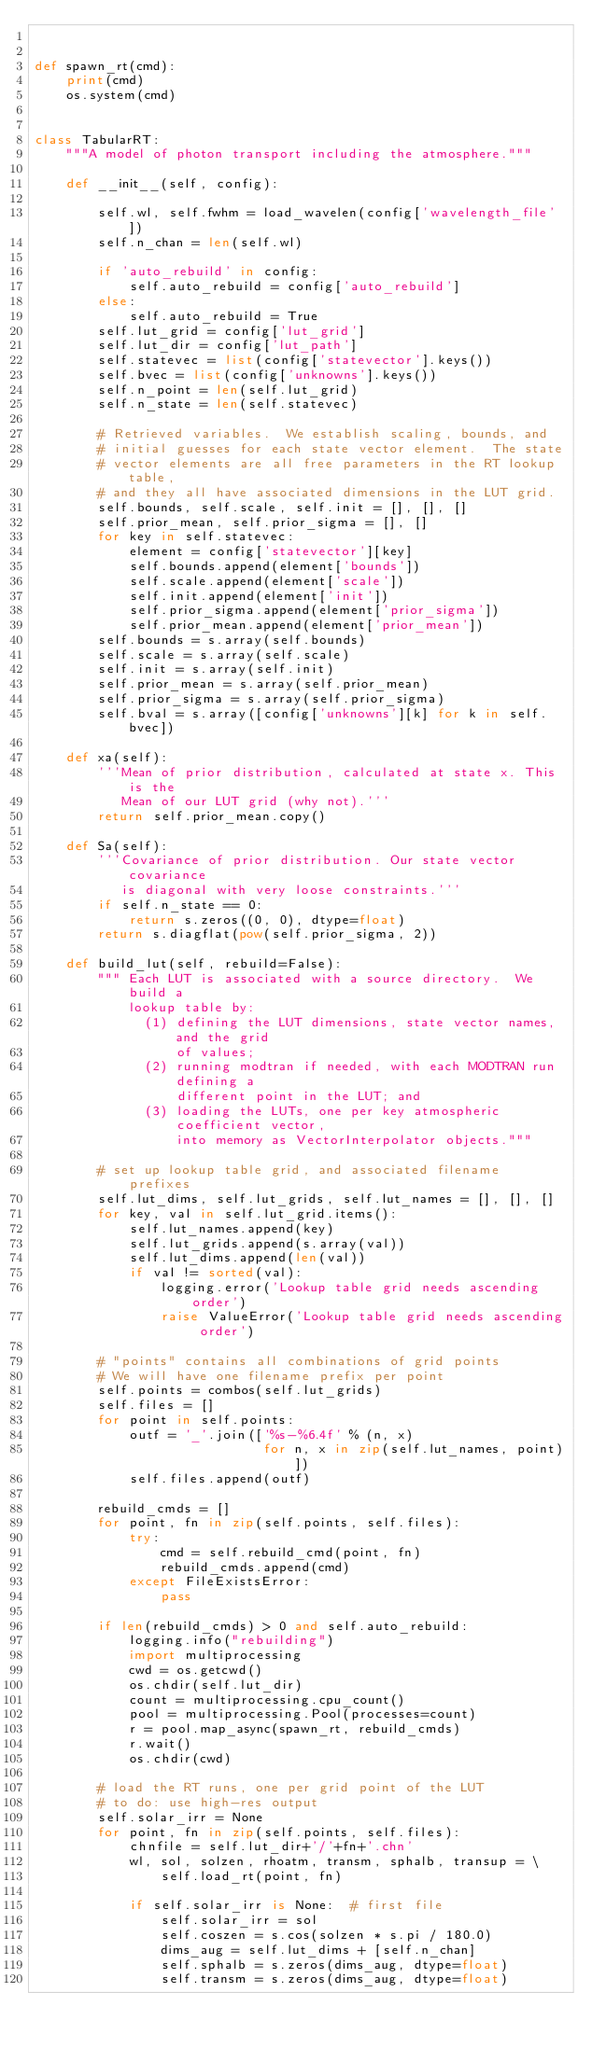<code> <loc_0><loc_0><loc_500><loc_500><_Python_>

def spawn_rt(cmd):
    print(cmd)
    os.system(cmd)


class TabularRT:
    """A model of photon transport including the atmosphere."""

    def __init__(self, config):

        self.wl, self.fwhm = load_wavelen(config['wavelength_file'])
        self.n_chan = len(self.wl)

        if 'auto_rebuild' in config:
            self.auto_rebuild = config['auto_rebuild']
        else:
            self.auto_rebuild = True
        self.lut_grid = config['lut_grid']
        self.lut_dir = config['lut_path']
        self.statevec = list(config['statevector'].keys())
        self.bvec = list(config['unknowns'].keys())
        self.n_point = len(self.lut_grid)
        self.n_state = len(self.statevec)

        # Retrieved variables.  We establish scaling, bounds, and
        # initial guesses for each state vector element.  The state
        # vector elements are all free parameters in the RT lookup table,
        # and they all have associated dimensions in the LUT grid.
        self.bounds, self.scale, self.init = [], [], []
        self.prior_mean, self.prior_sigma = [], []
        for key in self.statevec:
            element = config['statevector'][key]
            self.bounds.append(element['bounds'])
            self.scale.append(element['scale'])
            self.init.append(element['init'])
            self.prior_sigma.append(element['prior_sigma'])
            self.prior_mean.append(element['prior_mean'])
        self.bounds = s.array(self.bounds)
        self.scale = s.array(self.scale)
        self.init = s.array(self.init)
        self.prior_mean = s.array(self.prior_mean)
        self.prior_sigma = s.array(self.prior_sigma)
        self.bval = s.array([config['unknowns'][k] for k in self.bvec])

    def xa(self):
        '''Mean of prior distribution, calculated at state x. This is the
           Mean of our LUT grid (why not).'''
        return self.prior_mean.copy()

    def Sa(self):
        '''Covariance of prior distribution. Our state vector covariance 
           is diagonal with very loose constraints.'''
        if self.n_state == 0:
            return s.zeros((0, 0), dtype=float)
        return s.diagflat(pow(self.prior_sigma, 2))

    def build_lut(self, rebuild=False):
        """ Each LUT is associated with a source directory.  We build a 
            lookup table by: 
              (1) defining the LUT dimensions, state vector names, and the grid 
                  of values; 
              (2) running modtran if needed, with each MODTRAN run defining a 
                  different point in the LUT; and 
              (3) loading the LUTs, one per key atmospheric coefficient vector,
                  into memory as VectorInterpolator objects."""

        # set up lookup table grid, and associated filename prefixes
        self.lut_dims, self.lut_grids, self.lut_names = [], [], []
        for key, val in self.lut_grid.items():
            self.lut_names.append(key)
            self.lut_grids.append(s.array(val))
            self.lut_dims.append(len(val))
            if val != sorted(val):
                logging.error('Lookup table grid needs ascending order')
                raise ValueError('Lookup table grid needs ascending order')

        # "points" contains all combinations of grid points
        # We will have one filename prefix per point
        self.points = combos(self.lut_grids)
        self.files = []
        for point in self.points:
            outf = '_'.join(['%s-%6.4f' % (n, x)
                             for n, x in zip(self.lut_names, point)])
            self.files.append(outf)

        rebuild_cmds = []
        for point, fn in zip(self.points, self.files):
            try:
                cmd = self.rebuild_cmd(point, fn)
                rebuild_cmds.append(cmd)
            except FileExistsError:
                pass

        if len(rebuild_cmds) > 0 and self.auto_rebuild:
            logging.info("rebuilding")
            import multiprocessing
            cwd = os.getcwd()
            os.chdir(self.lut_dir)
            count = multiprocessing.cpu_count()
            pool = multiprocessing.Pool(processes=count)
            r = pool.map_async(spawn_rt, rebuild_cmds)
            r.wait()
            os.chdir(cwd)

        # load the RT runs, one per grid point of the LUT
        # to do: use high-res output
        self.solar_irr = None
        for point, fn in zip(self.points, self.files):
            chnfile = self.lut_dir+'/'+fn+'.chn'
            wl, sol, solzen, rhoatm, transm, sphalb, transup = \
                self.load_rt(point, fn)

            if self.solar_irr is None:  # first file
                self.solar_irr = sol
                self.coszen = s.cos(solzen * s.pi / 180.0)
                dims_aug = self.lut_dims + [self.n_chan]
                self.sphalb = s.zeros(dims_aug, dtype=float)
                self.transm = s.zeros(dims_aug, dtype=float)</code> 